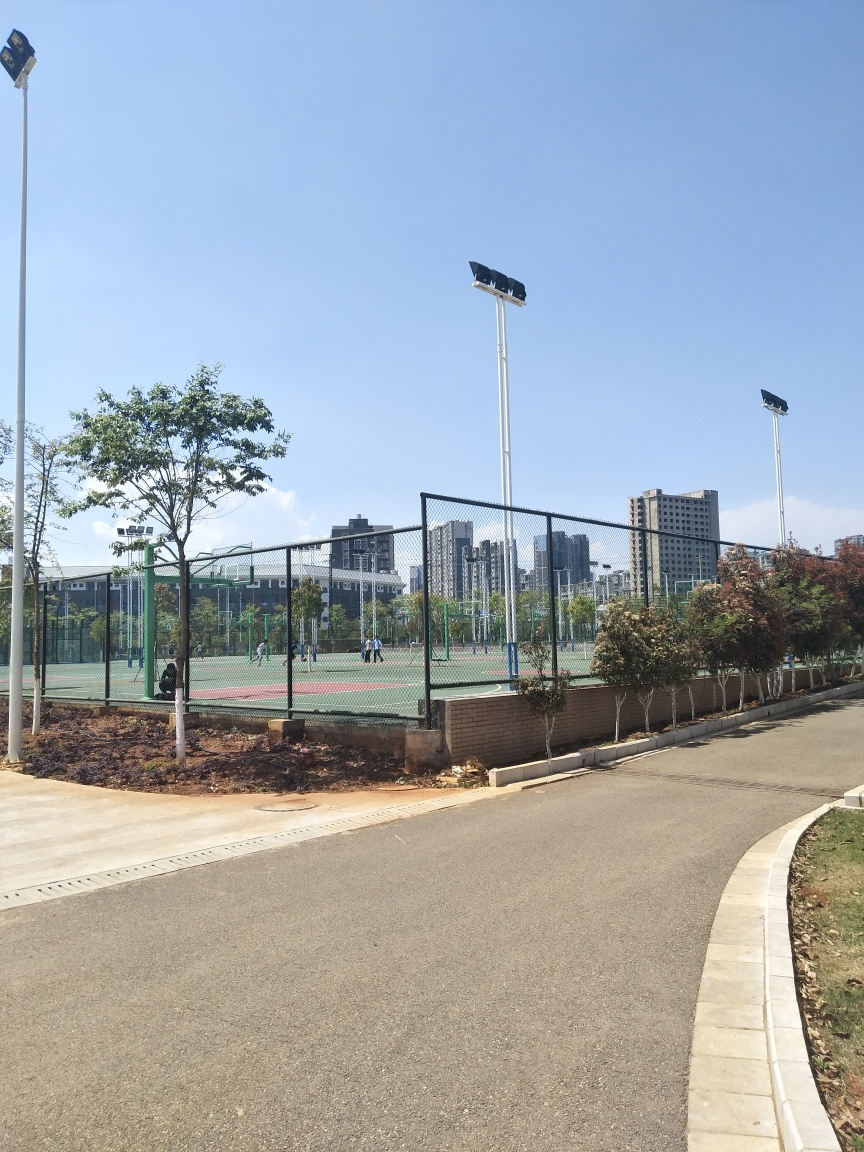Does the image appear clear and bright?
A. No
B. Yes
Answer with the option's letter from the given choices directly.
 B. 